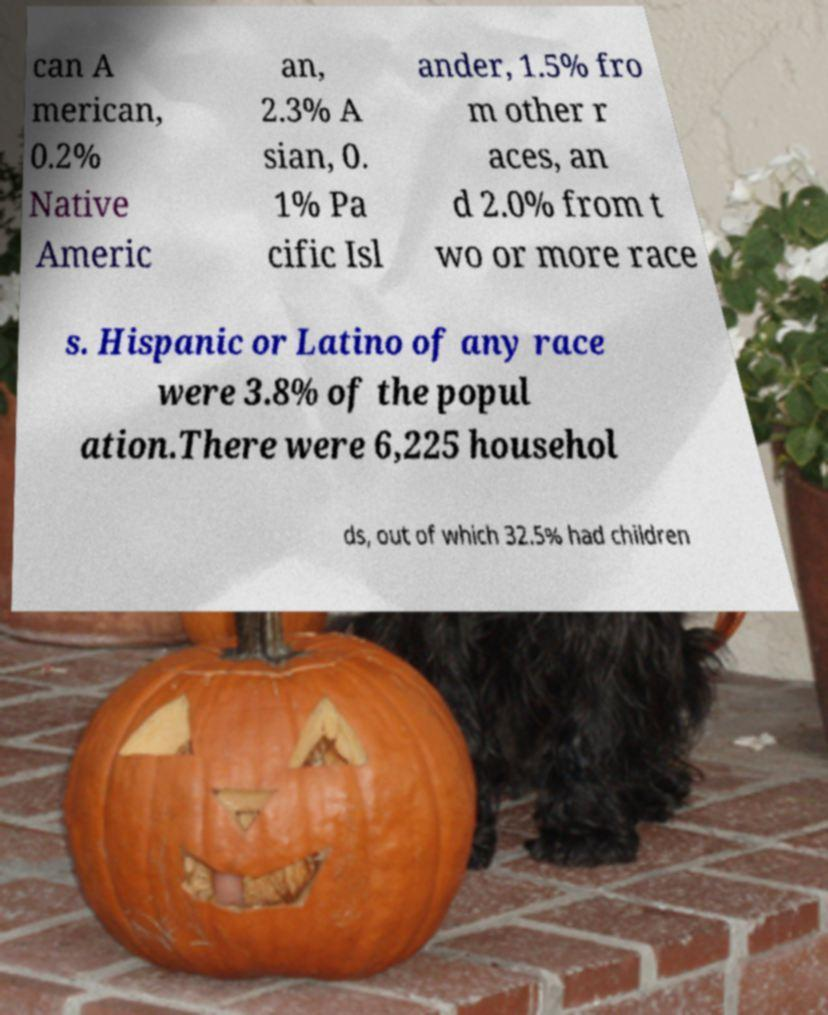For documentation purposes, I need the text within this image transcribed. Could you provide that? can A merican, 0.2% Native Americ an, 2.3% A sian, 0. 1% Pa cific Isl ander, 1.5% fro m other r aces, an d 2.0% from t wo or more race s. Hispanic or Latino of any race were 3.8% of the popul ation.There were 6,225 househol ds, out of which 32.5% had children 